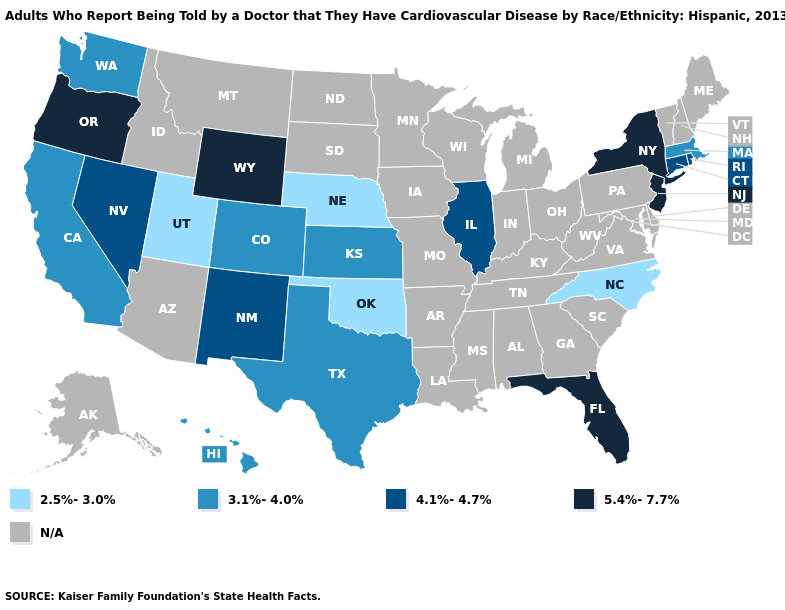Name the states that have a value in the range 2.5%-3.0%?
Concise answer only. Nebraska, North Carolina, Oklahoma, Utah. Does Florida have the lowest value in the South?
Give a very brief answer. No. Among the states that border Colorado , does Oklahoma have the highest value?
Concise answer only. No. Among the states that border Rhode Island , does Connecticut have the highest value?
Short answer required. Yes. Which states hav the highest value in the Northeast?
Write a very short answer. New Jersey, New York. Name the states that have a value in the range 2.5%-3.0%?
Keep it brief. Nebraska, North Carolina, Oklahoma, Utah. Name the states that have a value in the range 3.1%-4.0%?
Keep it brief. California, Colorado, Hawaii, Kansas, Massachusetts, Texas, Washington. Which states have the highest value in the USA?
Keep it brief. Florida, New Jersey, New York, Oregon, Wyoming. What is the highest value in the USA?
Give a very brief answer. 5.4%-7.7%. Among the states that border Delaware , which have the lowest value?
Short answer required. New Jersey. Does Florida have the highest value in the South?
Answer briefly. Yes. Name the states that have a value in the range 4.1%-4.7%?
Short answer required. Connecticut, Illinois, Nevada, New Mexico, Rhode Island. Which states have the lowest value in the USA?
Answer briefly. Nebraska, North Carolina, Oklahoma, Utah. Name the states that have a value in the range 3.1%-4.0%?
Be succinct. California, Colorado, Hawaii, Kansas, Massachusetts, Texas, Washington. Which states have the lowest value in the Northeast?
Quick response, please. Massachusetts. 